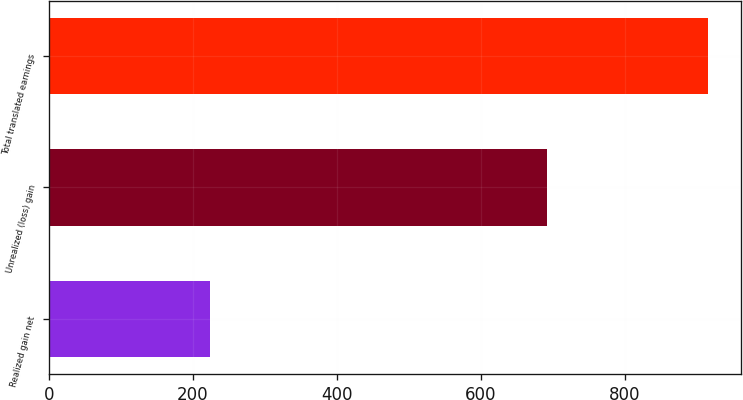<chart> <loc_0><loc_0><loc_500><loc_500><bar_chart><fcel>Realized gain net<fcel>Unrealized (loss) gain<fcel>Total translated earnings<nl><fcel>224<fcel>692<fcel>916<nl></chart> 